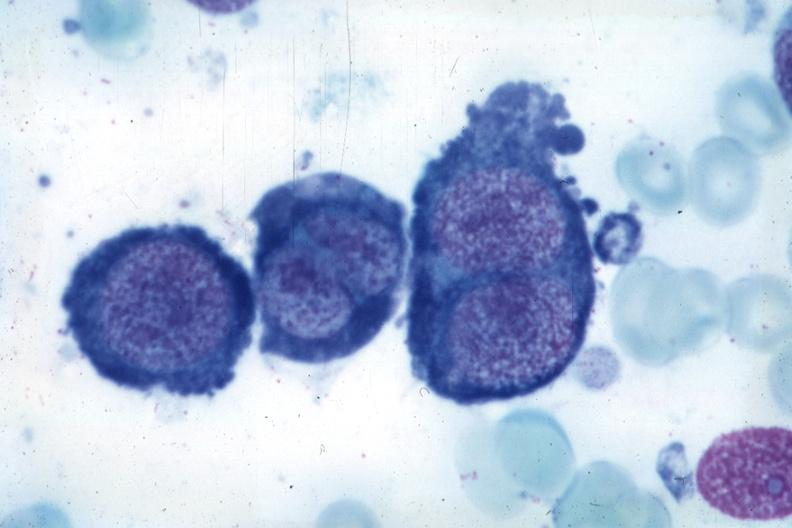s megaloblasts pernicious anemia present?
Answer the question using a single word or phrase. Yes 